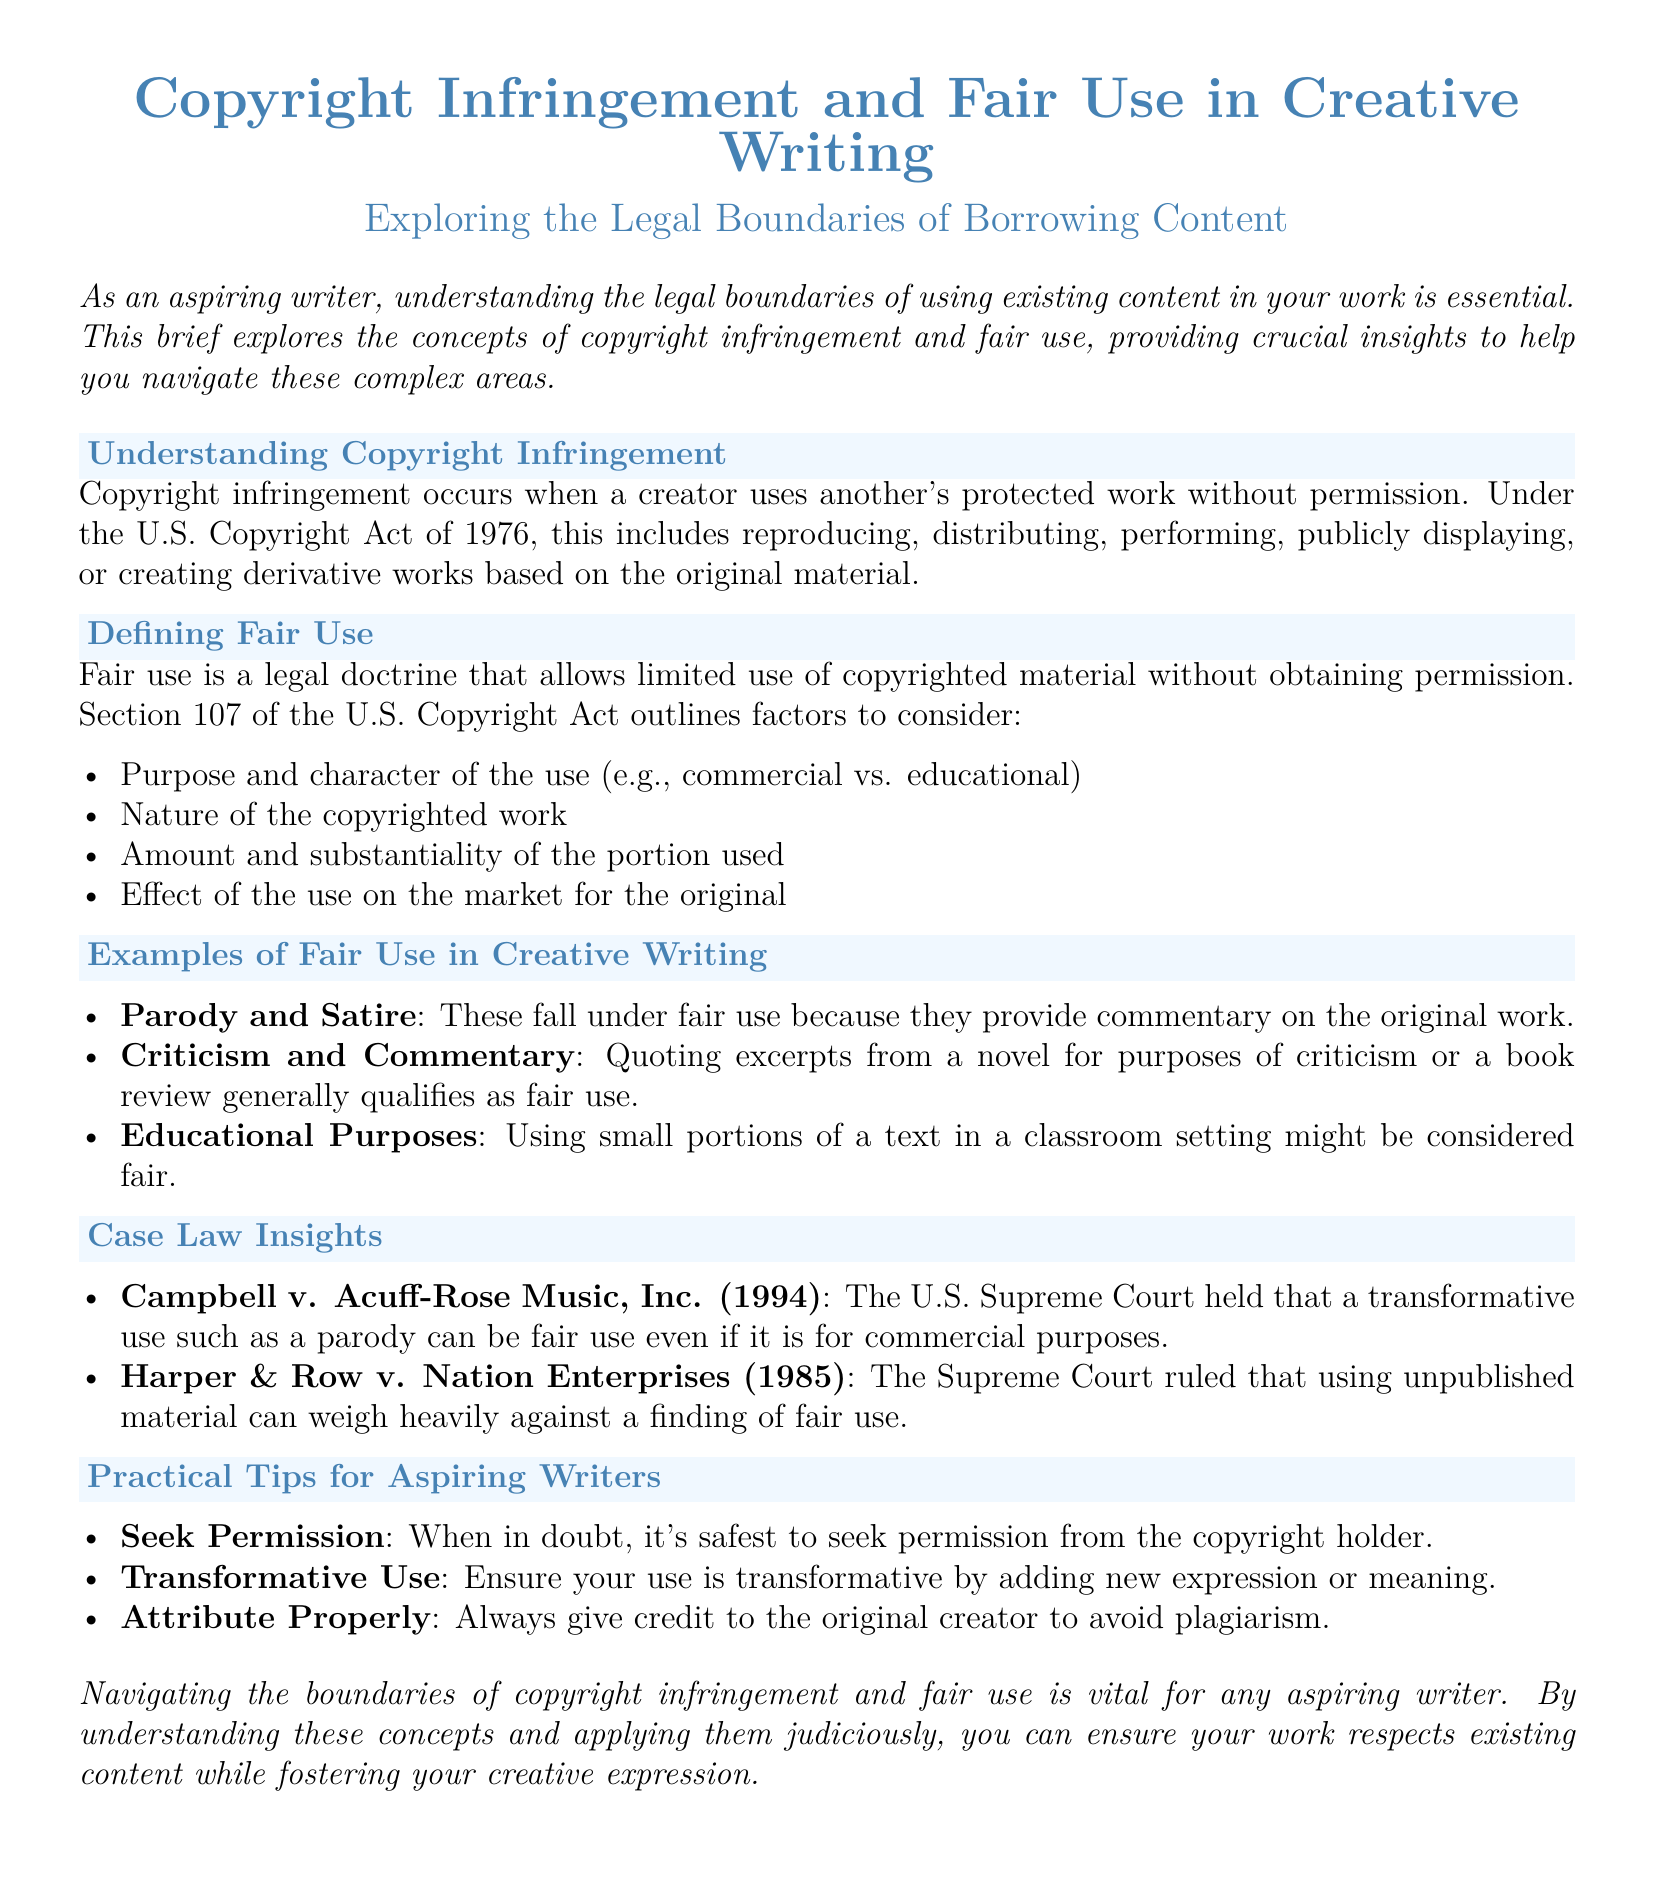What is copyright infringement? Copyright infringement occurs when a creator uses another's protected work without permission.
Answer: Use without permission What year was the U.S. Copyright Act enacted? The document references the U.S. Copyright Act of 1976 as the relevant law for copyright infringement.
Answer: 1976 What are the four factors of fair use? The document lists the factors to consider for fair use, specifically purpose, nature, amount, and effect.
Answer: Purpose, nature, amount, effect Which case addressed transformative use in parody? The document mentions Campbell v. Acuff-Rose Music, Inc. as a case pertaining to transformative use in parody.
Answer: Campbell v. Acuff-Rose Music, Inc What should writers do when in doubt about permissions? The document advises writers to seek permission from the copyright holder when uncertain.
Answer: Seek permission What type of use is typically considered fair for educational purposes? The document suggests that using small portions of a text in a classroom might be considered fair use.
Answer: Small portions in classrooms What must be ensured for a use to be transformative? The document states that transformative use requires adding new expression or meaning.
Answer: New expression or meaning What legal doctrine allows for limited use of copyrighted material? The document defines fair use as the legal doctrine allowing such limited use.
Answer: Fair use 